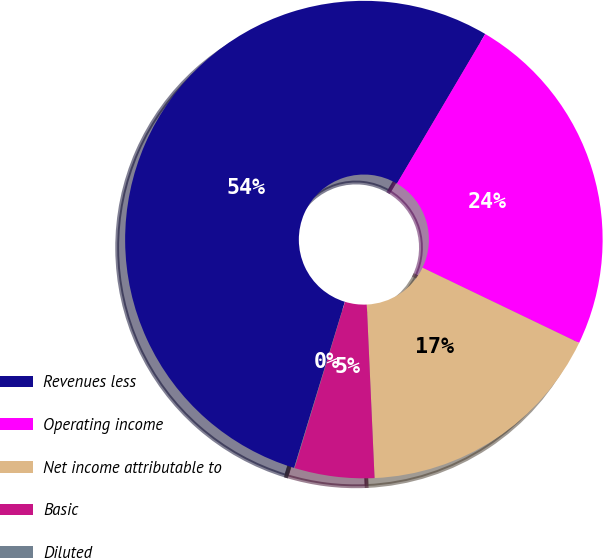Convert chart to OTSL. <chart><loc_0><loc_0><loc_500><loc_500><pie_chart><fcel>Revenues less<fcel>Operating income<fcel>Net income attributable to<fcel>Basic<fcel>Diluted<nl><fcel>53.77%<fcel>23.64%<fcel>17.16%<fcel>5.4%<fcel>0.03%<nl></chart> 